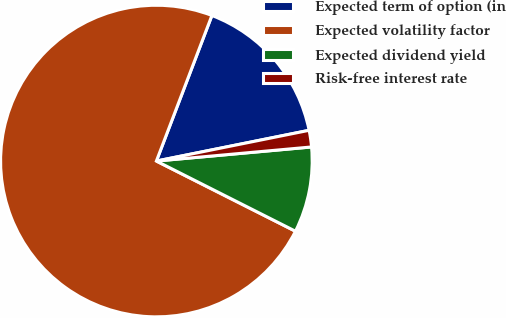Convert chart. <chart><loc_0><loc_0><loc_500><loc_500><pie_chart><fcel>Expected term of option (in<fcel>Expected volatility factor<fcel>Expected dividend yield<fcel>Risk-free interest rate<nl><fcel>16.04%<fcel>73.36%<fcel>8.88%<fcel>1.72%<nl></chart> 